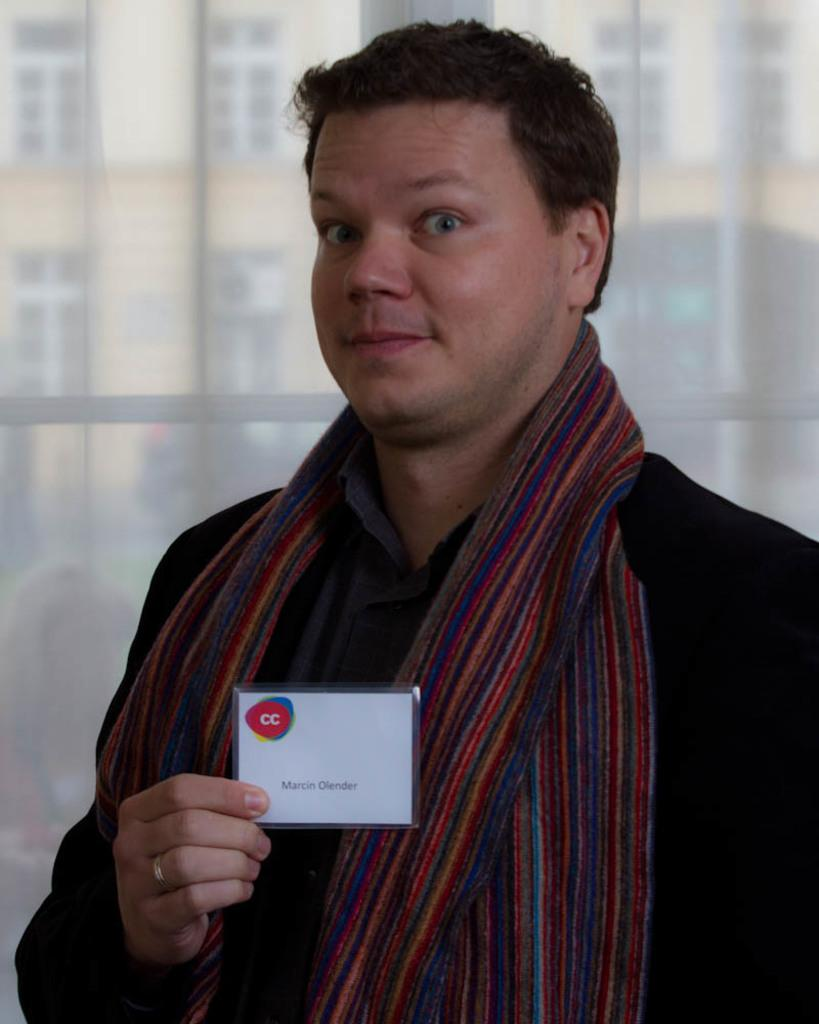What is the person in the image holding? The person is holding a card with text in the image. What can be seen in the background of the image? There is a glass in the background of the image. What is visible through the glass? A building is visible through the glass. What type of frame is used to display the card in the image? There is no frame present in the image; the card is simply being held by the person. 